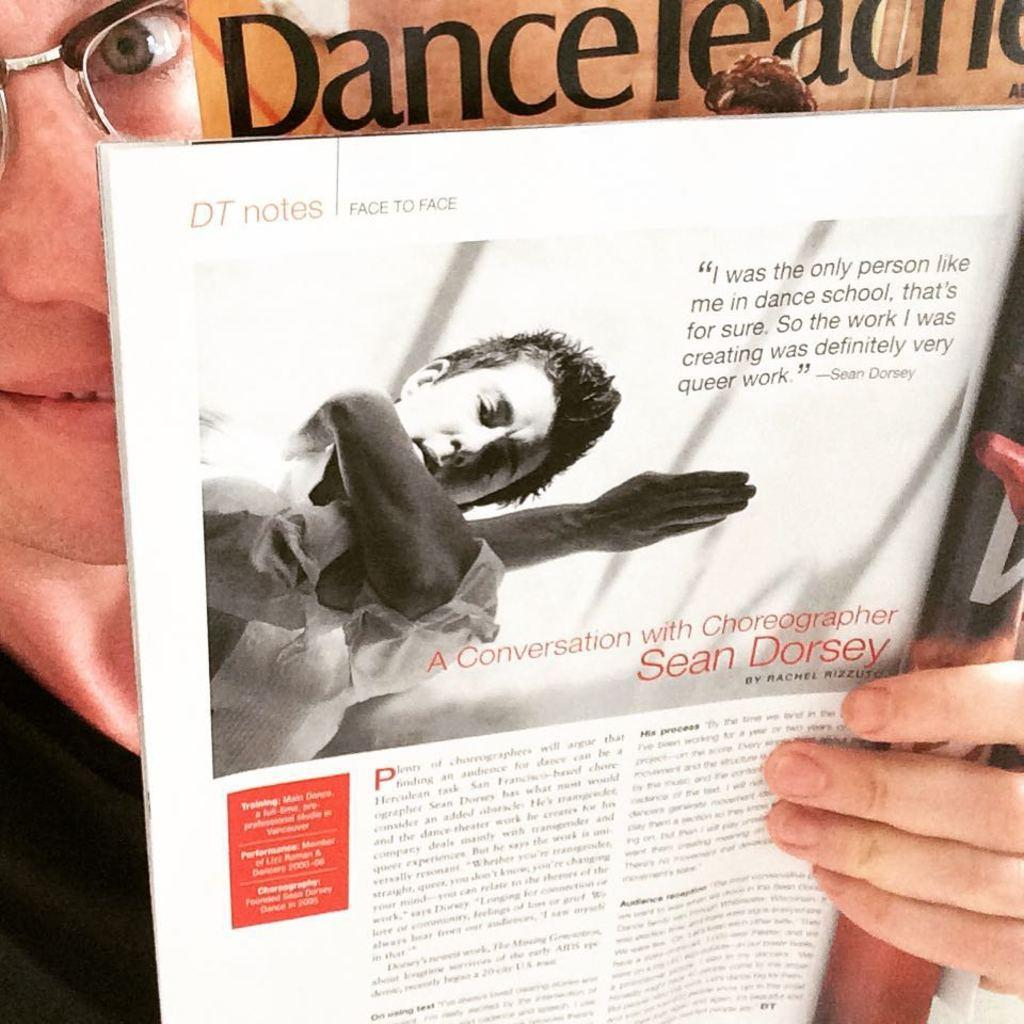<image>
Describe the image concisely. A dance magazine is opened to a conversation with choreographer Sean Dorsey. 